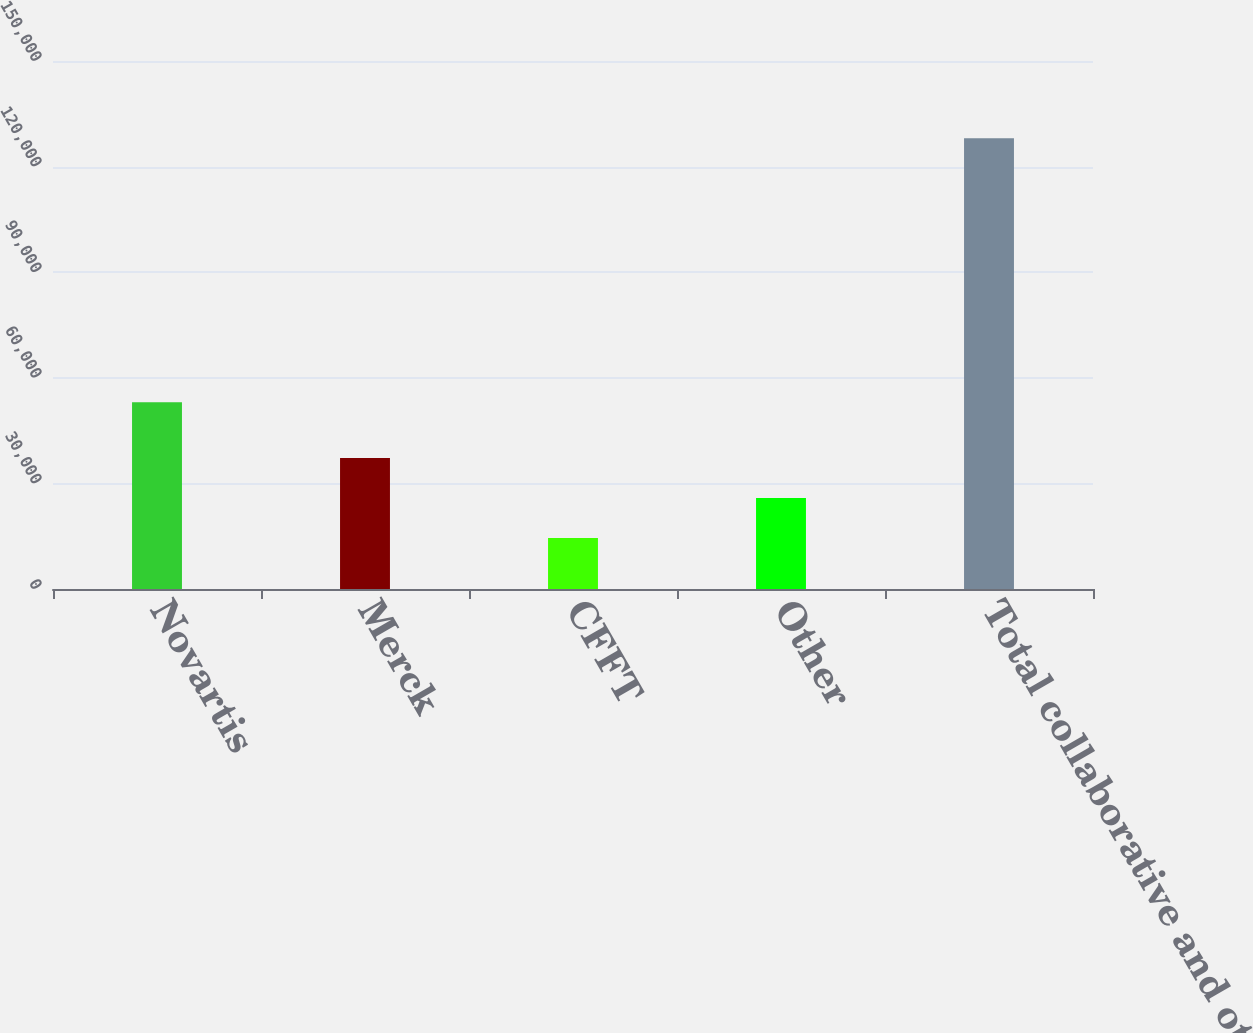<chart> <loc_0><loc_0><loc_500><loc_500><bar_chart><fcel>Novartis<fcel>Merck<fcel>CFFT<fcel>Other<fcel>Total collaborative and other<nl><fcel>53082<fcel>37204.2<fcel>14490<fcel>25847.1<fcel>128061<nl></chart> 